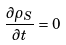Convert formula to latex. <formula><loc_0><loc_0><loc_500><loc_500>\frac { \partial \rho _ { S } } { \partial t } = 0</formula> 